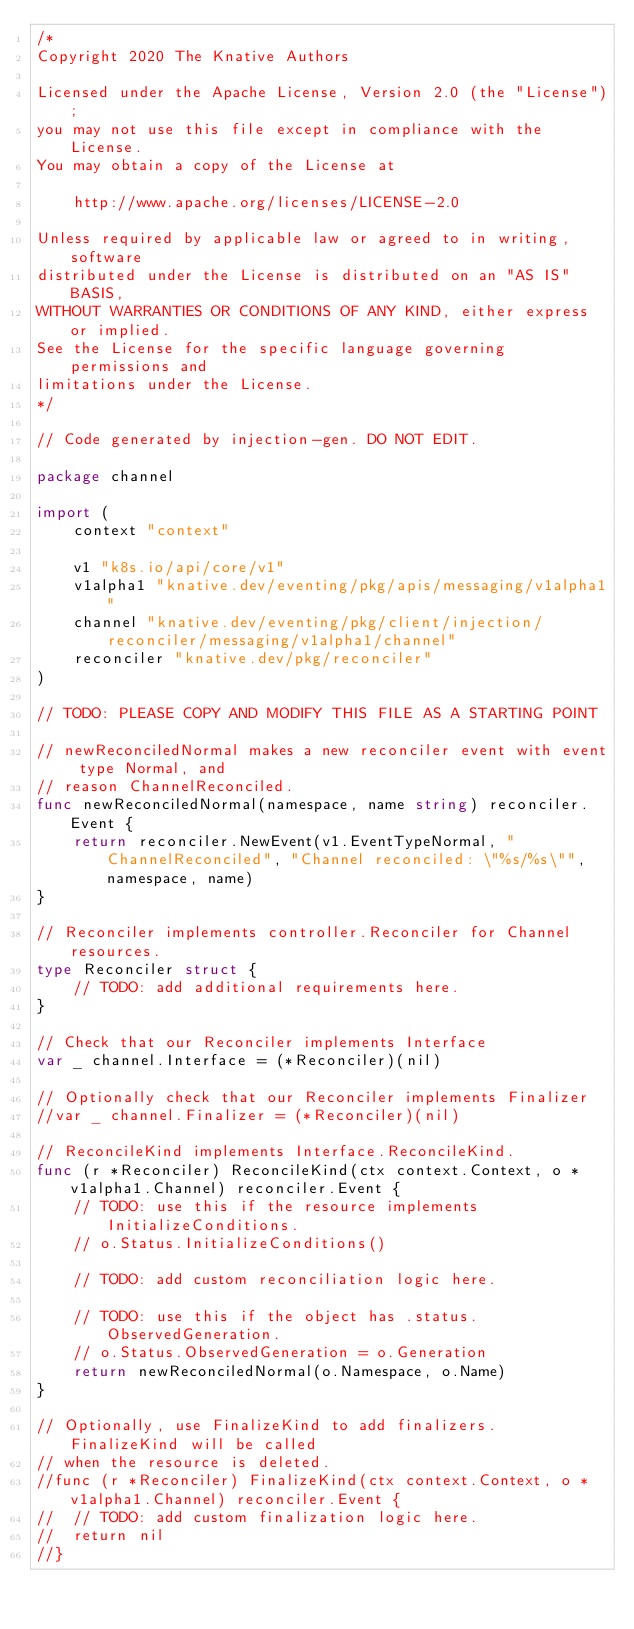<code> <loc_0><loc_0><loc_500><loc_500><_Go_>/*
Copyright 2020 The Knative Authors

Licensed under the Apache License, Version 2.0 (the "License");
you may not use this file except in compliance with the License.
You may obtain a copy of the License at

    http://www.apache.org/licenses/LICENSE-2.0

Unless required by applicable law or agreed to in writing, software
distributed under the License is distributed on an "AS IS" BASIS,
WITHOUT WARRANTIES OR CONDITIONS OF ANY KIND, either express or implied.
See the License for the specific language governing permissions and
limitations under the License.
*/

// Code generated by injection-gen. DO NOT EDIT.

package channel

import (
	context "context"

	v1 "k8s.io/api/core/v1"
	v1alpha1 "knative.dev/eventing/pkg/apis/messaging/v1alpha1"
	channel "knative.dev/eventing/pkg/client/injection/reconciler/messaging/v1alpha1/channel"
	reconciler "knative.dev/pkg/reconciler"
)

// TODO: PLEASE COPY AND MODIFY THIS FILE AS A STARTING POINT

// newReconciledNormal makes a new reconciler event with event type Normal, and
// reason ChannelReconciled.
func newReconciledNormal(namespace, name string) reconciler.Event {
	return reconciler.NewEvent(v1.EventTypeNormal, "ChannelReconciled", "Channel reconciled: \"%s/%s\"", namespace, name)
}

// Reconciler implements controller.Reconciler for Channel resources.
type Reconciler struct {
	// TODO: add additional requirements here.
}

// Check that our Reconciler implements Interface
var _ channel.Interface = (*Reconciler)(nil)

// Optionally check that our Reconciler implements Finalizer
//var _ channel.Finalizer = (*Reconciler)(nil)

// ReconcileKind implements Interface.ReconcileKind.
func (r *Reconciler) ReconcileKind(ctx context.Context, o *v1alpha1.Channel) reconciler.Event {
	// TODO: use this if the resource implements InitializeConditions.
	// o.Status.InitializeConditions()

	// TODO: add custom reconciliation logic here.

	// TODO: use this if the object has .status.ObservedGeneration.
	// o.Status.ObservedGeneration = o.Generation
	return newReconciledNormal(o.Namespace, o.Name)
}

// Optionally, use FinalizeKind to add finalizers. FinalizeKind will be called
// when the resource is deleted.
//func (r *Reconciler) FinalizeKind(ctx context.Context, o *v1alpha1.Channel) reconciler.Event {
//	// TODO: add custom finalization logic here.
//	return nil
//}
</code> 